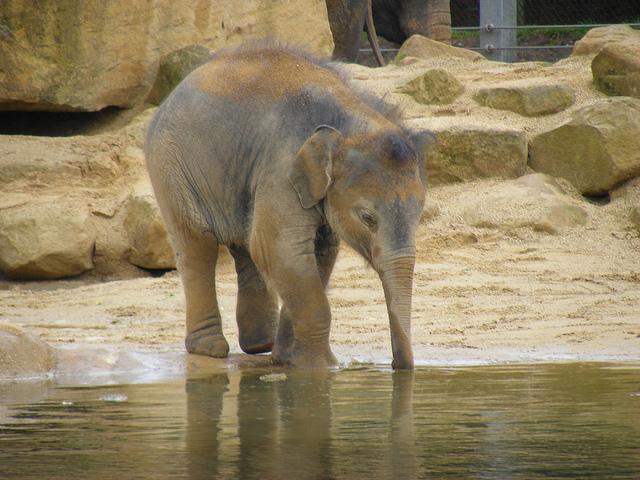What color is the elephant?
Concise answer only. Gray. Is this a full grown elephant?
Answer briefly. No. Is the elephant drinking?
Keep it brief. Yes. 